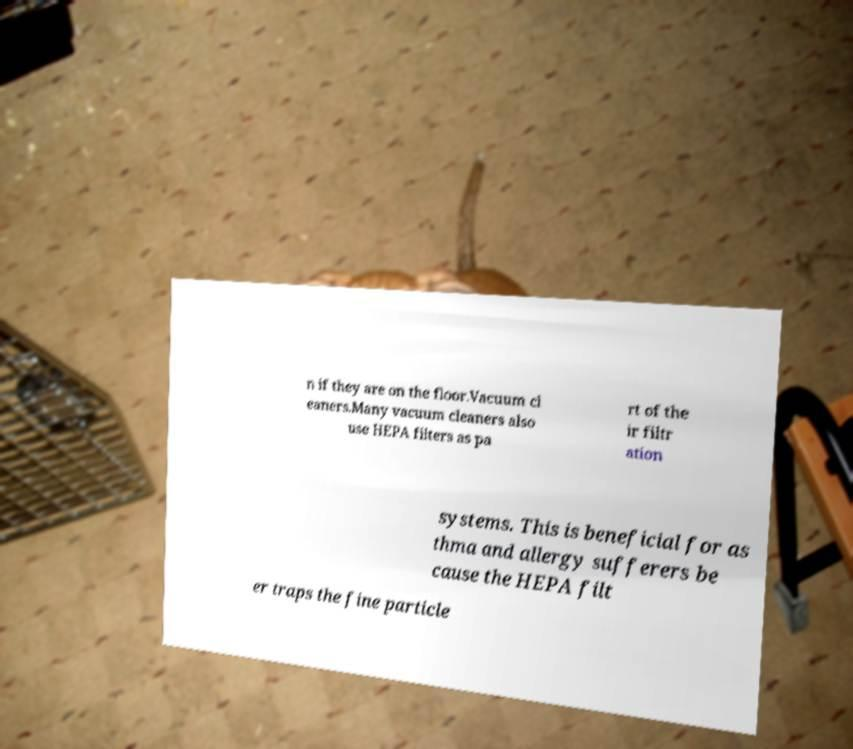There's text embedded in this image that I need extracted. Can you transcribe it verbatim? n if they are on the floor.Vacuum cl eaners.Many vacuum cleaners also use HEPA filters as pa rt of the ir filtr ation systems. This is beneficial for as thma and allergy sufferers be cause the HEPA filt er traps the fine particle 